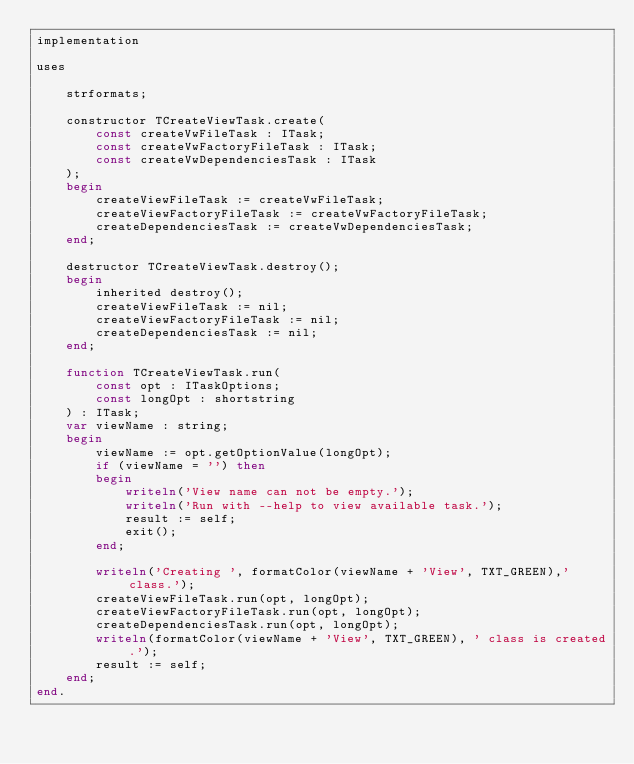Convert code to text. <code><loc_0><loc_0><loc_500><loc_500><_Pascal_>implementation

uses

    strformats;

    constructor TCreateViewTask.create(
        const createVwFileTask : ITask;
        const createVwFactoryFileTask : ITask;
        const createVwDependenciesTask : ITask
    );
    begin
        createViewFileTask := createVwFileTask;
        createViewFactoryFileTask := createVwFactoryFileTask;
        createDependenciesTask := createVwDependenciesTask;
    end;

    destructor TCreateViewTask.destroy();
    begin
        inherited destroy();
        createViewFileTask := nil;
        createViewFactoryFileTask := nil;
        createDependenciesTask := nil;
    end;

    function TCreateViewTask.run(
        const opt : ITaskOptions;
        const longOpt : shortstring
    ) : ITask;
    var viewName : string;
    begin
        viewName := opt.getOptionValue(longOpt);
        if (viewName = '') then
        begin
            writeln('View name can not be empty.');
            writeln('Run with --help to view available task.');
            result := self;
            exit();
        end;

        writeln('Creating ', formatColor(viewName + 'View', TXT_GREEN),' class.');
        createViewFileTask.run(opt, longOpt);
        createViewFactoryFileTask.run(opt, longOpt);
        createDependenciesTask.run(opt, longOpt);
        writeln(formatColor(viewName + 'View', TXT_GREEN), ' class is created.');
        result := self;
    end;
end.
</code> 